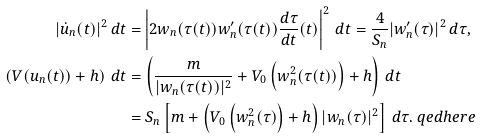<formula> <loc_0><loc_0><loc_500><loc_500>| \dot { u } _ { n } ( t ) | ^ { 2 } \, d t & = \left | 2 w _ { n } ( \tau ( t ) ) w _ { n } ^ { \prime } ( \tau ( t ) ) \frac { d \tau } { d t } ( t ) \right | ^ { 2 } \, d t = \frac { 4 } { S _ { n } } | w _ { n } ^ { \prime } ( \tau ) | ^ { 2 } \, d \tau , \\ \left ( V ( u _ { n } ( t ) ) + h \right ) \, d t & = \left ( \frac { m } { | w _ { n } ( \tau ( t ) ) | ^ { 2 } } + V _ { 0 } \left ( w _ { n } ^ { 2 } ( \tau ( t ) ) \right ) + h \right ) \, d t \\ & = S _ { n } \left [ m + \left ( V _ { 0 } \left ( w _ { n } ^ { 2 } ( \tau ) \right ) + h \right ) | w _ { n } ( \tau ) | ^ { 2 } \right ] \, d \tau . \ q e d h e r e</formula> 